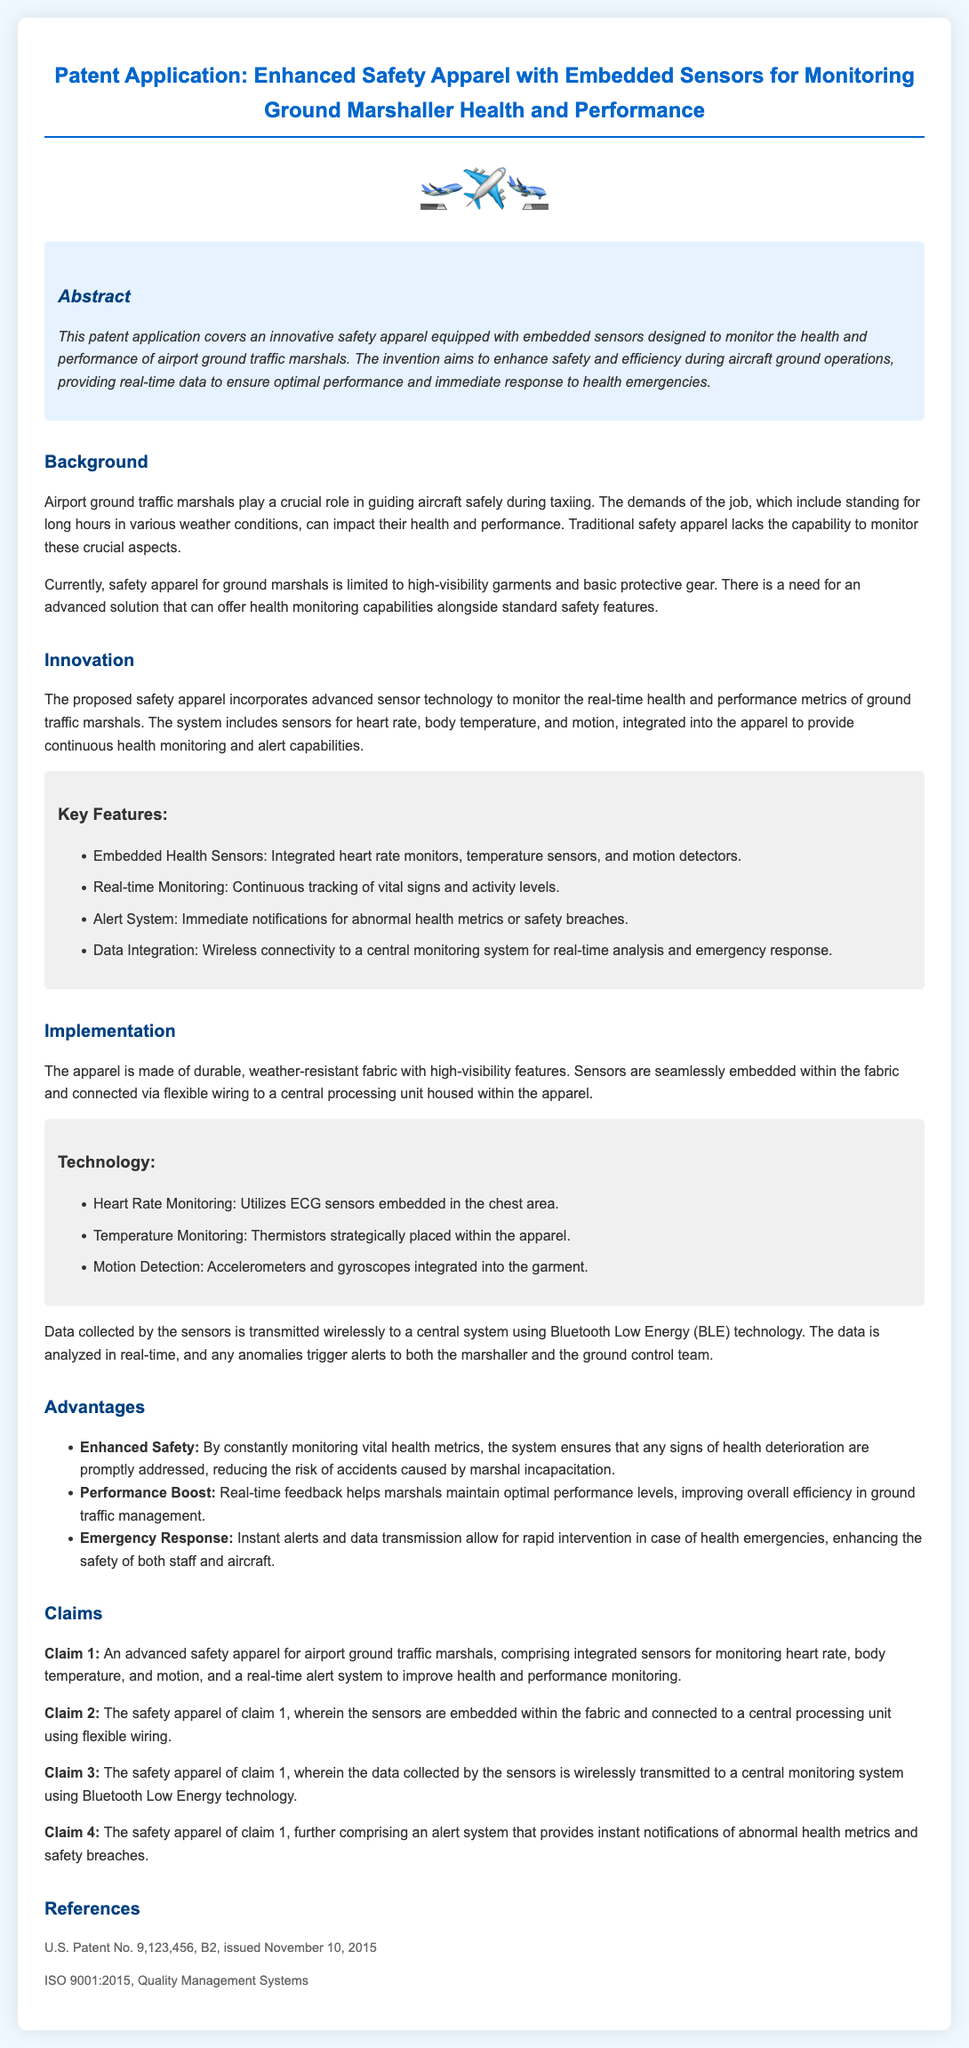What is the title of the patent application? The title is a formal designation given to the patent and it is mentioned at the top of the document.
Answer: Enhanced Safety Apparel with Embedded Sensors for Monitoring Ground Marshaller Health and Performance What type of sensors are mentioned in the patent? The sensors are specific components designed to monitor various health metrics, as stated in the key features section.
Answer: Heart rate monitors, temperature sensors, and motion detectors What year was the related U.S. patent issued? The document provides the issue date of the related patent, which is important for reference.
Answer: 2015 What technology is used for data transmission? The specific technology for wireless communication is outlined in the technology section.
Answer: Bluetooth Low Energy What is the main benefit of real-time monitoring? The advantages section explains the benefits of constant monitoring for the marshaller's health during operations.
Answer: Enhanced safety How many claims are listed in the patent application? The claims section specifies the number of formal statements of the invention’s features.
Answer: Four Which feature of the apparel enhances emergency response? This feature relates to the ability to notify the relevant authorities of health issues.
Answer: Alert system What does the background mention as a challenge for ground marshals? The background discusses the physical challenges faced by marshals in their job, leading to health concerns.
Answer: Long hours What is the material of the apparel? The implementation section provides details on the construction and materials used in the apparel.
Answer: Durable, weather-resistant fabric 